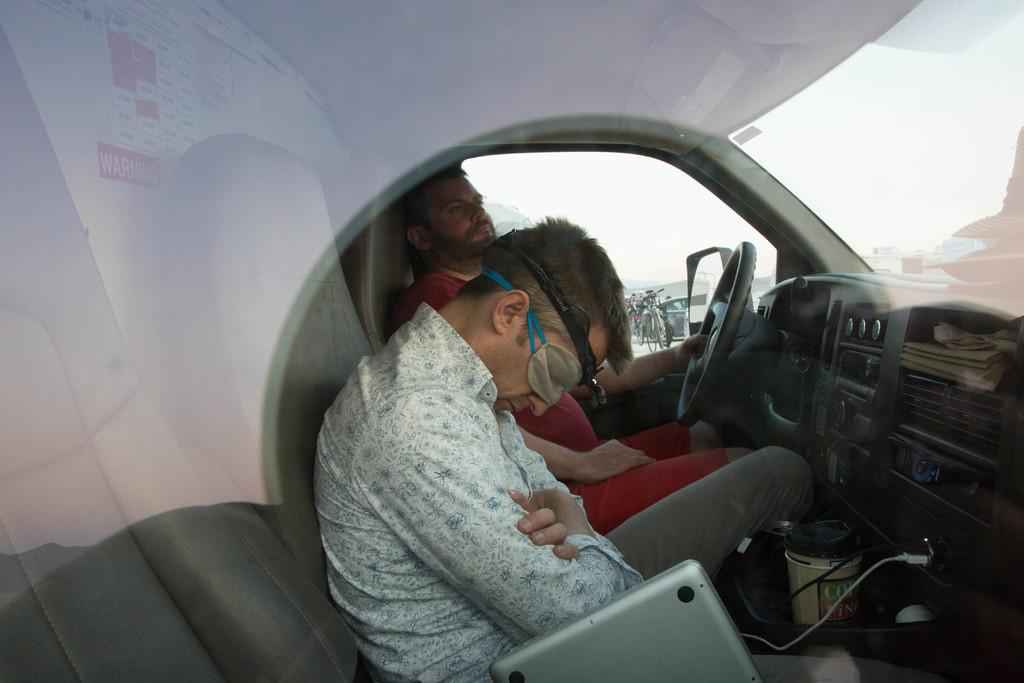What is the setting of the image? The image shows the inside of a vehicle. Who or what is present inside the vehicle? There are people in the vehicle. What can be seen through the windows or windshield of the vehicle? The background of the image includes the sky and other objects visible in the background. Can you tell me how many goats are visible in the image? There are no goats present in the image; it shows the inside of a vehicle with people. Who is the owner of the vehicle in the image? The facts provided do not mention the owner of the vehicle, so we cannot determine that information from the image. 